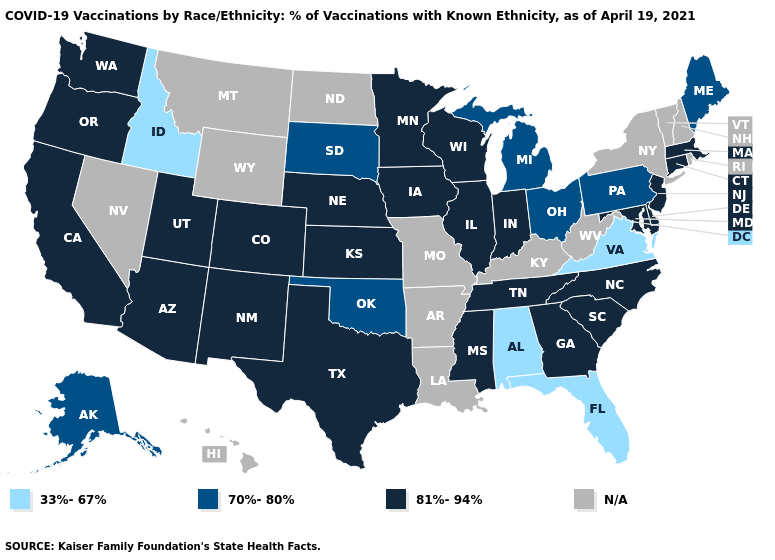Name the states that have a value in the range 33%-67%?
Write a very short answer. Alabama, Florida, Idaho, Virginia. What is the highest value in states that border Minnesota?
Write a very short answer. 81%-94%. What is the value of Texas?
Write a very short answer. 81%-94%. Name the states that have a value in the range N/A?
Be succinct. Arkansas, Hawaii, Kentucky, Louisiana, Missouri, Montana, Nevada, New Hampshire, New York, North Dakota, Rhode Island, Vermont, West Virginia, Wyoming. How many symbols are there in the legend?
Write a very short answer. 4. Name the states that have a value in the range 33%-67%?
Answer briefly. Alabama, Florida, Idaho, Virginia. Among the states that border New Mexico , does Oklahoma have the lowest value?
Give a very brief answer. Yes. Name the states that have a value in the range 81%-94%?
Short answer required. Arizona, California, Colorado, Connecticut, Delaware, Georgia, Illinois, Indiana, Iowa, Kansas, Maryland, Massachusetts, Minnesota, Mississippi, Nebraska, New Jersey, New Mexico, North Carolina, Oregon, South Carolina, Tennessee, Texas, Utah, Washington, Wisconsin. What is the value of Utah?
Answer briefly. 81%-94%. Does Massachusetts have the highest value in the Northeast?
Be succinct. Yes. Name the states that have a value in the range N/A?
Quick response, please. Arkansas, Hawaii, Kentucky, Louisiana, Missouri, Montana, Nevada, New Hampshire, New York, North Dakota, Rhode Island, Vermont, West Virginia, Wyoming. Does Massachusetts have the lowest value in the Northeast?
Keep it brief. No. Among the states that border Texas , which have the lowest value?
Keep it brief. Oklahoma. 